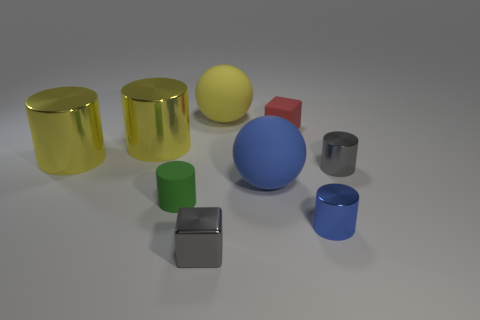Add 1 blue metal cylinders. How many objects exist? 10 Subtract all blue cylinders. How many cylinders are left? 4 Subtract all blocks. How many objects are left? 7 Add 2 tiny green rubber cylinders. How many tiny green rubber cylinders are left? 3 Add 3 large green blocks. How many large green blocks exist? 3 Subtract all blue cylinders. How many cylinders are left? 4 Subtract 0 cyan balls. How many objects are left? 9 Subtract 5 cylinders. How many cylinders are left? 0 Subtract all purple cylinders. Subtract all green blocks. How many cylinders are left? 5 Subtract all cyan cylinders. How many red blocks are left? 1 